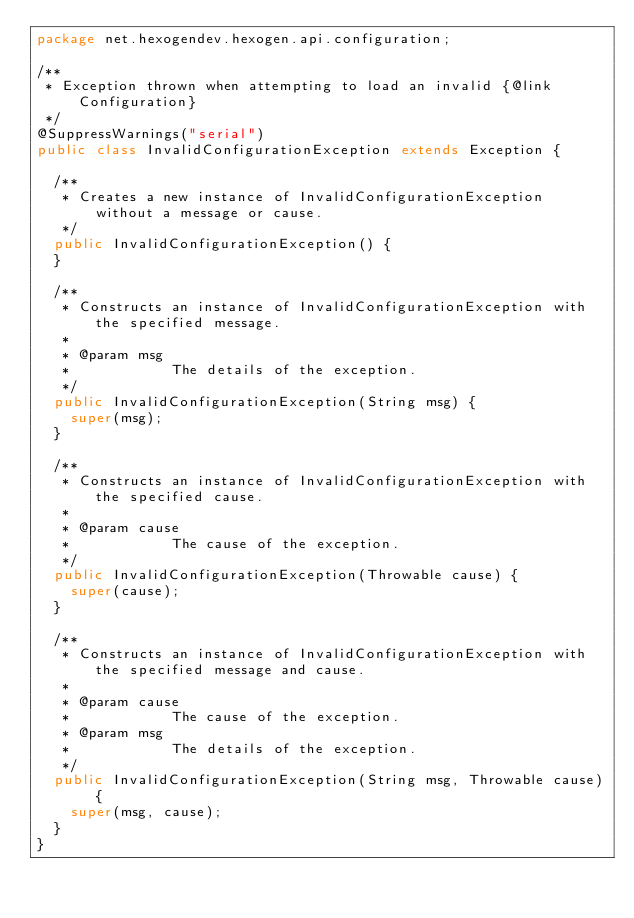Convert code to text. <code><loc_0><loc_0><loc_500><loc_500><_Java_>package net.hexogendev.hexogen.api.configuration;

/**
 * Exception thrown when attempting to load an invalid {@link Configuration}
 */
@SuppressWarnings("serial")
public class InvalidConfigurationException extends Exception {

	/**
	 * Creates a new instance of InvalidConfigurationException without a message or cause.
	 */
	public InvalidConfigurationException() {
	}

	/**
	 * Constructs an instance of InvalidConfigurationException with the specified message.
	 *
	 * @param msg
	 *            The details of the exception.
	 */
	public InvalidConfigurationException(String msg) {
		super(msg);
	}

	/**
	 * Constructs an instance of InvalidConfigurationException with the specified cause.
	 *
	 * @param cause
	 *            The cause of the exception.
	 */
	public InvalidConfigurationException(Throwable cause) {
		super(cause);
	}

	/**
	 * Constructs an instance of InvalidConfigurationException with the specified message and cause.
	 *
	 * @param cause
	 *            The cause of the exception.
	 * @param msg
	 *            The details of the exception.
	 */
	public InvalidConfigurationException(String msg, Throwable cause) {
		super(msg, cause);
	}
}
</code> 